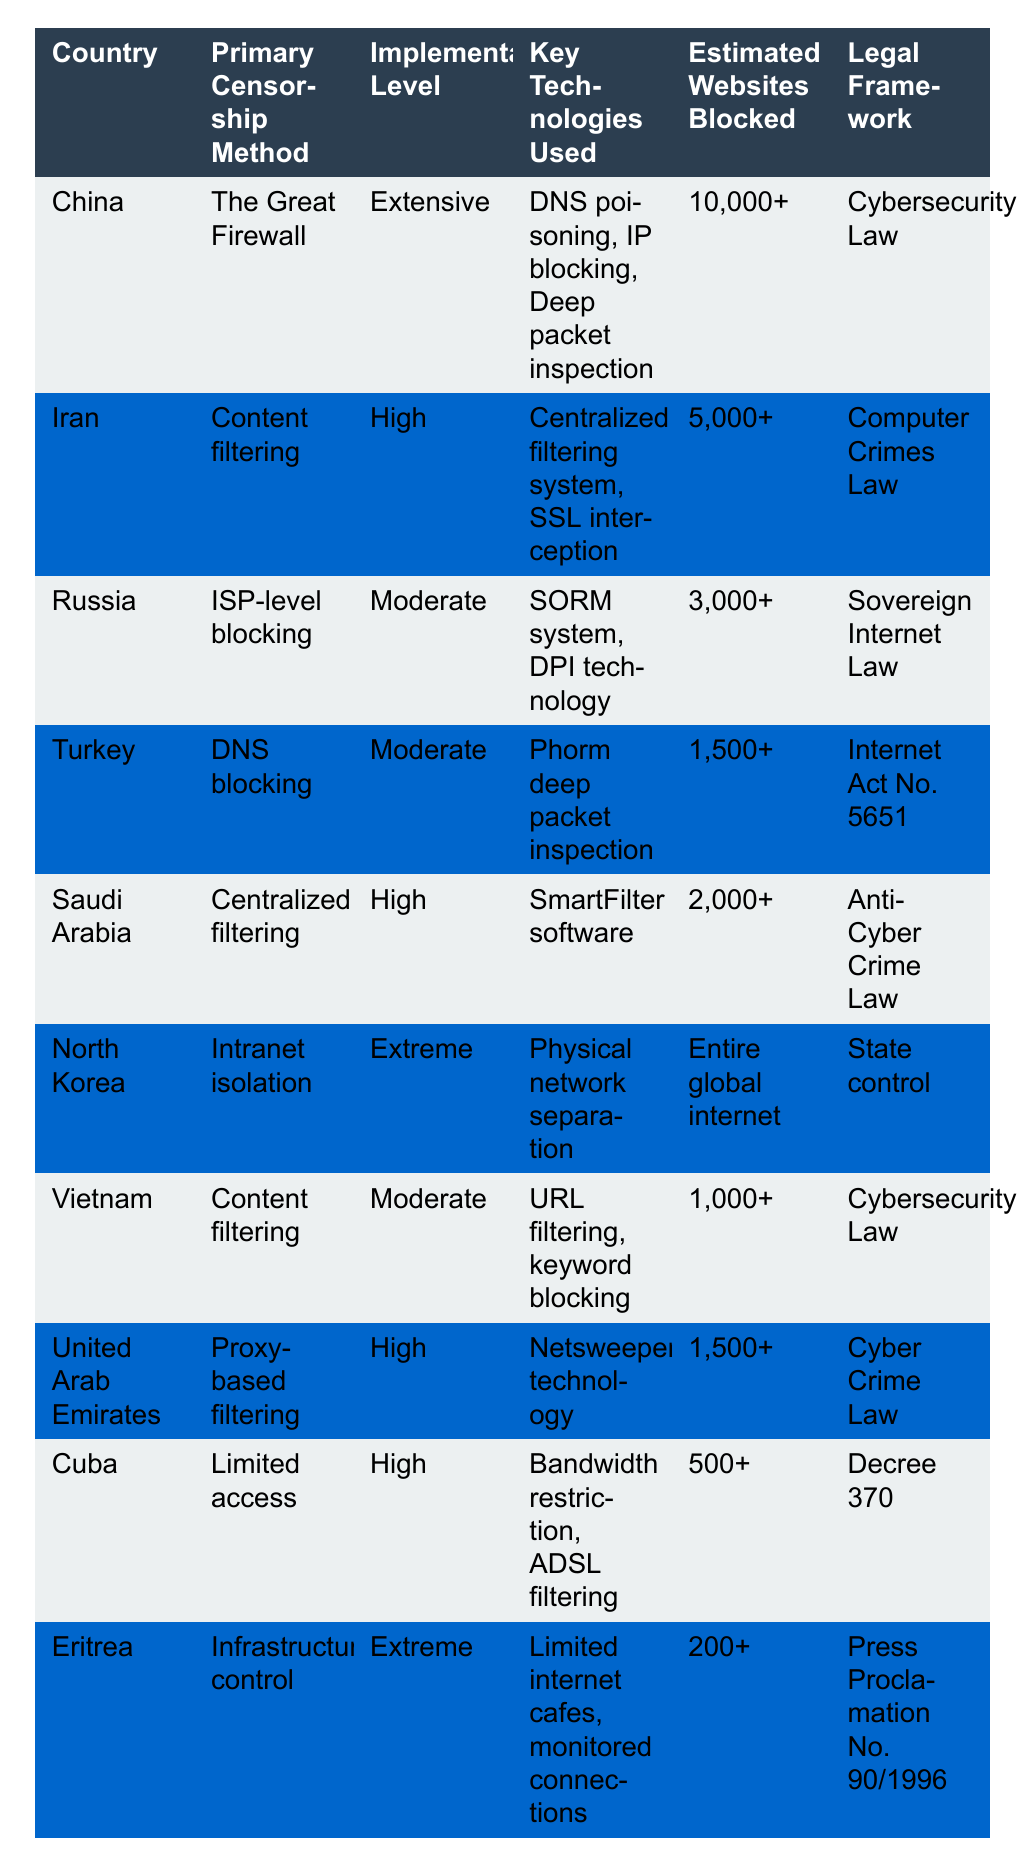What is the primary censorship method used in China? The table states that China's primary censorship method is "The Great Firewall."
Answer: The Great Firewall Which country has the highest estimated number of websites blocked? By examining the "Estimated Websites Blocked" column, China has over 10,000 blocked websites, which is the highest in the table.
Answer: China Is the implementation level of censorship in North Korea categorized as extensive? The table classifies North Korea's implementation level as "Extreme," which does not match "Extensive."
Answer: No What are the key technologies used by Iran for internet censorship? According to the table, Iran uses a "Centralized filtering system" and "SSL interception" as key technologies for censorship.
Answer: Centralized filtering system, SSL interception How does the primary censorship method in Russia compare to that in Turkey? Russia uses "ISP-level blocking" while Turkey employs "DNS blocking," indicating different approaches.
Answer: Different approaches List the countries that employ content filtering as their primary censorship method. The table shows that Iran and Vietnam both use content filtering as their primary method.
Answer: Iran, Vietnam Which legal framework is associated with the internet censorship in Saudi Arabia? The table indicates that Saudi Arabia's internet censorship is governed by the "Anti-Cyber Crime Law."
Answer: Anti-Cyber Crime Law If we consider the estimated websites blocked, what is the total for both Vietnam and Turkey? Vietnam has approximately 1,000 blocked websites and Turkey around 1,500, totaling 2,500 when added together (1,000 + 1,500 = 2,500).
Answer: 2,500 What can be inferred about the level of internet censorship in countries with an "Extreme" implementation level? The countries with "Extreme" implementation (North Korea and Eritrea) show a high degree of control, suggesting severe restrictions on internet access.
Answer: Severe restrictions Is the legal framework in the UAE categorized under cybersecurity laws? The table shows that the UAE's legal framework falls under the "Cyber Crime Law," which is distinct from cybersecurity laws.
Answer: No 